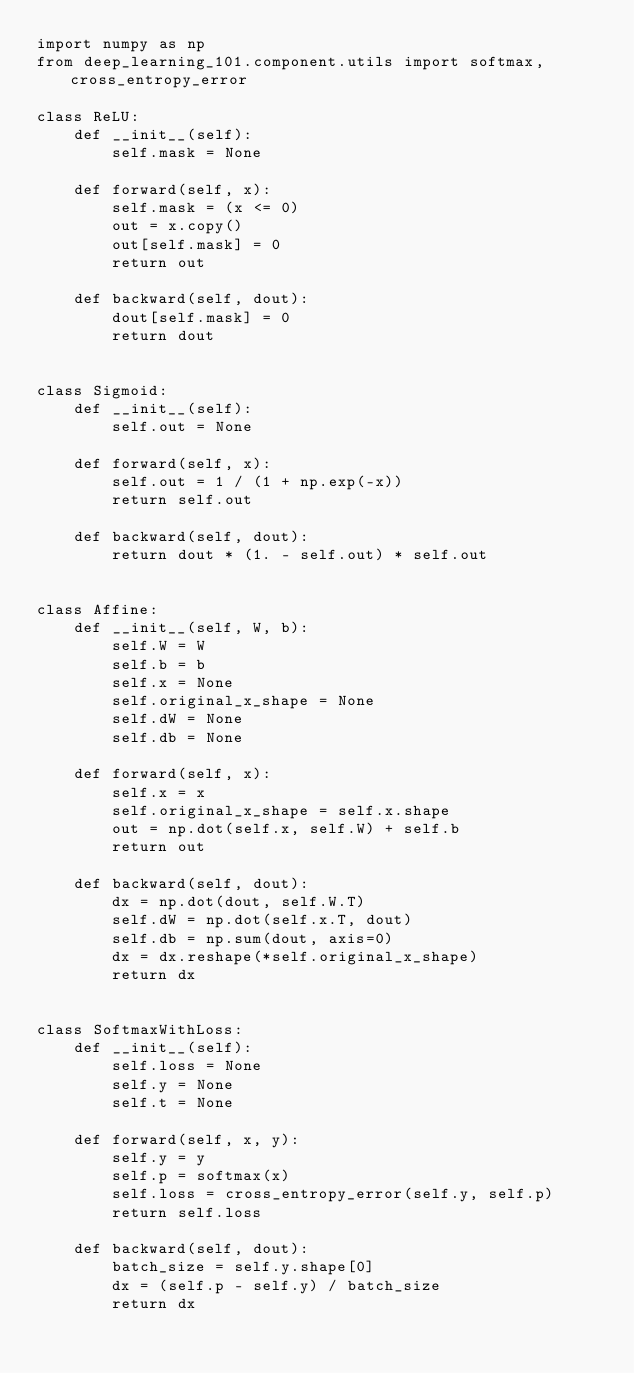Convert code to text. <code><loc_0><loc_0><loc_500><loc_500><_Python_>import numpy as np
from deep_learning_101.component.utils import softmax, cross_entropy_error

class ReLU:
    def __init__(self):
        self.mask = None

    def forward(self, x):
        self.mask = (x <= 0)
        out = x.copy()
        out[self.mask] = 0
        return out

    def backward(self, dout):
        dout[self.mask] = 0
        return dout


class Sigmoid:
    def __init__(self):
        self.out = None

    def forward(self, x):
        self.out = 1 / (1 + np.exp(-x))
        return self.out

    def backward(self, dout):
        return dout * (1. - self.out) * self.out


class Affine:
    def __init__(self, W, b):
        self.W = W
        self.b = b
        self.x = None
        self.original_x_shape = None
        self.dW = None
        self.db = None

    def forward(self, x):
        self.x = x
        self.original_x_shape = self.x.shape
        out = np.dot(self.x, self.W) + self.b
        return out

    def backward(self, dout):
        dx = np.dot(dout, self.W.T)
        self.dW = np.dot(self.x.T, dout)
        self.db = np.sum(dout, axis=0)
        dx = dx.reshape(*self.original_x_shape)
        return dx


class SoftmaxWithLoss:
    def __init__(self):
        self.loss = None
        self.y = None
        self.t = None

    def forward(self, x, y):
        self.y = y
        self.p = softmax(x)
        self.loss = cross_entropy_error(self.y, self.p)
        return self.loss

    def backward(self, dout):
        batch_size = self.y.shape[0]
        dx = (self.p - self.y) / batch_size
        return dx
</code> 